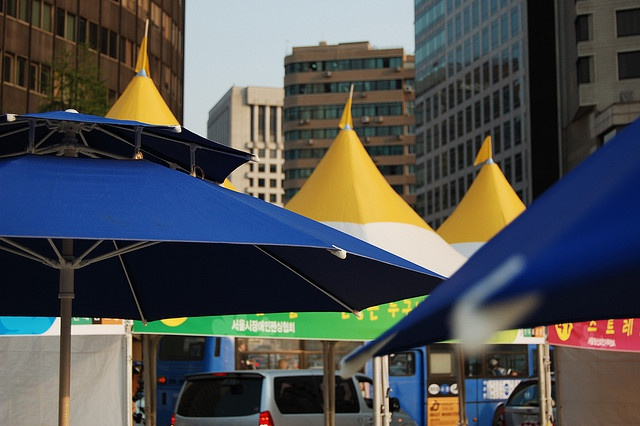Describe the objects in this image and their specific colors. I can see umbrella in black, blue, darkblue, and navy tones, umbrella in black, navy, gray, and darkgray tones, bus in black, blue, gray, and navy tones, umbrella in black, orange, navy, and gold tones, and car in black, gray, and darkgray tones in this image. 